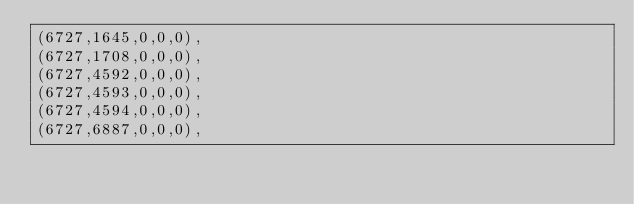Convert code to text. <code><loc_0><loc_0><loc_500><loc_500><_SQL_>(6727,1645,0,0,0),
(6727,1708,0,0,0),
(6727,4592,0,0,0),
(6727,4593,0,0,0),
(6727,4594,0,0,0),
(6727,6887,0,0,0),</code> 